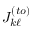Convert formula to latex. <formula><loc_0><loc_0><loc_500><loc_500>J _ { k \ell } ^ { ( t o ) }</formula> 